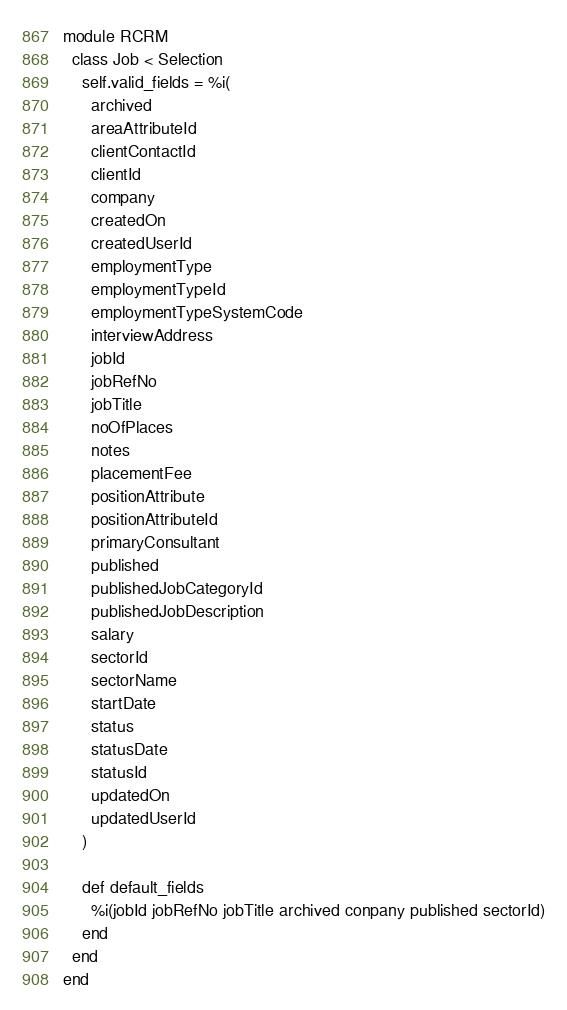<code> <loc_0><loc_0><loc_500><loc_500><_Ruby_>module RCRM
  class Job < Selection
    self.valid_fields = %i(
      archived
      areaAttributeId
      clientContactId
      clientId
      company
      createdOn
      createdUserId
      employmentType
      employmentTypeId
      employmentTypeSystemCode
      interviewAddress
      jobId
      jobRefNo
      jobTitle
      noOfPlaces
      notes
      placementFee
      positionAttribute
      positionAttributeId
      primaryConsultant
      published
      publishedJobCategoryId
      publishedJobDescription
      salary
      sectorId
      sectorName
      startDate
      status
      statusDate
      statusId
      updatedOn
      updatedUserId
    )

    def default_fields
      %i(jobId jobRefNo jobTitle archived conpany published sectorId)
    end
  end
end
</code> 